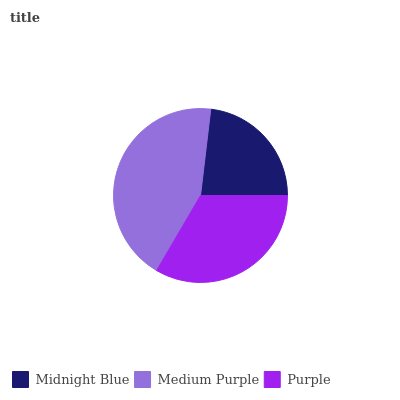Is Midnight Blue the minimum?
Answer yes or no. Yes. Is Medium Purple the maximum?
Answer yes or no. Yes. Is Purple the minimum?
Answer yes or no. No. Is Purple the maximum?
Answer yes or no. No. Is Medium Purple greater than Purple?
Answer yes or no. Yes. Is Purple less than Medium Purple?
Answer yes or no. Yes. Is Purple greater than Medium Purple?
Answer yes or no. No. Is Medium Purple less than Purple?
Answer yes or no. No. Is Purple the high median?
Answer yes or no. Yes. Is Purple the low median?
Answer yes or no. Yes. Is Midnight Blue the high median?
Answer yes or no. No. Is Midnight Blue the low median?
Answer yes or no. No. 